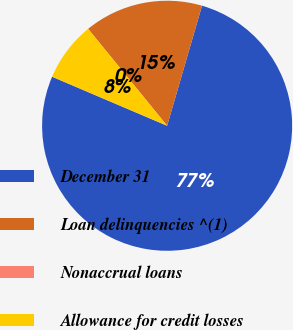Convert chart to OTSL. <chart><loc_0><loc_0><loc_500><loc_500><pie_chart><fcel>December 31<fcel>Loan delinquencies ^(1)<fcel>Nonaccrual loans<fcel>Allowance for credit losses<nl><fcel>76.91%<fcel>15.39%<fcel>0.0%<fcel>7.7%<nl></chart> 